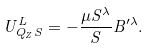<formula> <loc_0><loc_0><loc_500><loc_500>U _ { Q _ { Z } S } ^ { L } = - \frac { \mu S ^ { \lambda } } { S } { B } ^ { \prime \lambda } .</formula> 